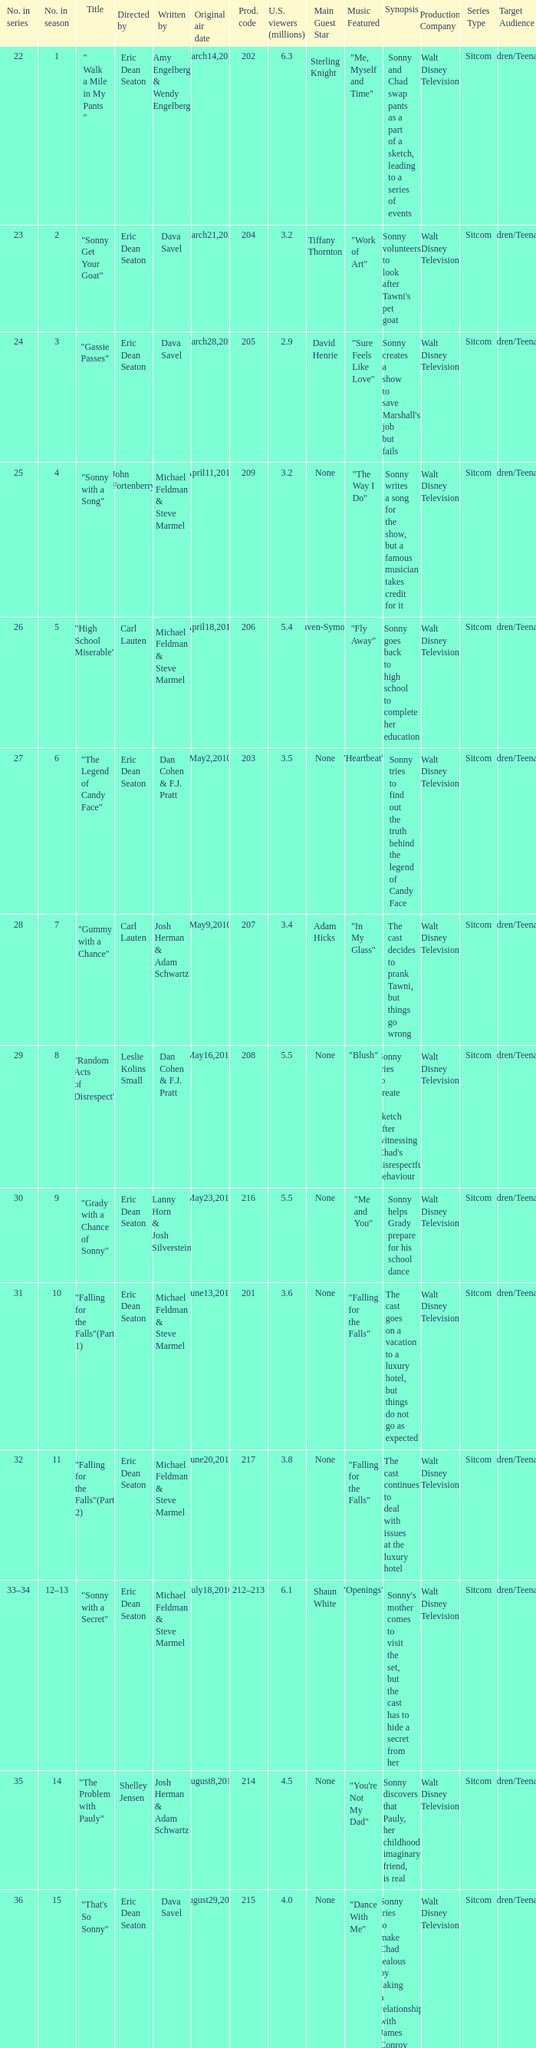Could you help me parse every detail presented in this table? {'header': ['No. in series', 'No. in season', 'Title', 'Directed by', 'Written by', 'Original air date', 'Prod. code', 'U.S. viewers (millions)', 'Main Guest Star', 'Music Featured', 'Synopsis', 'Production Company', 'Series Type', 'Target Audience'], 'rows': [['22', '1', '" Walk a Mile in My Pants "', 'Eric Dean Seaton', 'Amy Engelberg & Wendy Engelberg', 'March14,2010', '202', '6.3', 'Sterling Knight', '"Me, Myself and Time"', 'Sonny and Chad swap pants as a part of a sketch, leading to a series of events', 'Walt Disney Television', 'Sitcom', 'Children/Teenagers'], ['23', '2', '"Sonny Get Your Goat"', 'Eric Dean Seaton', 'Dava Savel', 'March21,2010', '204', '3.2', 'Tiffany Thornton', '"Work of Art"', "Sonny volunteers to look after Tawni's pet goat", 'Walt Disney Television', 'Sitcom', 'Children/Teenagers'], ['24', '3', '"Gassie Passes"', 'Eric Dean Seaton', 'Dava Savel', 'March28,2010', '205', '2.9', 'David Henrie', '"Sure Feels Like Love"', "Sonny creates a show to save Marshall's job but fails", 'Walt Disney Television', 'Sitcom', 'Children/Teenagers'], ['25', '4', '"Sonny with a Song"', 'John Fortenberry', 'Michael Feldman & Steve Marmel', 'April11,2010', '209', '3.2', 'None', '"The Way I Do"', 'Sonny writes a song for the show, but a famous musician takes credit for it', 'Walt Disney Television', 'Sitcom', 'Children/Teenagers'], ['26', '5', '"High School Miserable"', 'Carl Lauten', 'Michael Feldman & Steve Marmel', 'April18,2010', '206', '5.4', 'Raven-Symone', '"Fly Away"', 'Sonny goes back to high school to complete her education', 'Walt Disney Television', 'Sitcom', 'Children/Teenagers'], ['27', '6', '"The Legend of Candy Face"', 'Eric Dean Seaton', 'Dan Cohen & F.J. Pratt', 'May2,2010', '203', '3.5', 'None', '"Heartbeat"', 'Sonny tries to find out the truth behind the legend of Candy Face', 'Walt Disney Television', 'Sitcom', 'Children/Teenagers'], ['28', '7', '"Gummy with a Chance"', 'Carl Lauten', 'Josh Herman & Adam Schwartz', 'May9,2010', '207', '3.4', 'Adam Hicks', '"In My Glass"', 'The cast decides to prank Tawni, but things go wrong', 'Walt Disney Television', 'Sitcom', 'Children/Teenagers'], ['29', '8', '"Random Acts of Disrespect"', 'Leslie Kolins Small', 'Dan Cohen & F.J. Pratt', 'May16,2010', '208', '5.5', 'None', '"Blush"', "Sonny tries to create a sketch after witnessing Chad's disrespectful behaviour", 'Walt Disney Television', 'Sitcom', 'Children/Teenagers'], ['30', '9', '"Grady with a Chance of Sonny"', 'Eric Dean Seaton', 'Lanny Horn & Josh Silverstein', 'May23,2010', '216', '5.5', 'None', '"Me and You"', 'Sonny helps Grady prepare for his school dance', 'Walt Disney Television', 'Sitcom', 'Children/Teenagers'], ['31', '10', '"Falling for the Falls"(Part 1)', 'Eric Dean Seaton', 'Michael Feldman & Steve Marmel', 'June13,2010', '201', '3.6', 'None', '"Falling for the Falls"', 'The cast goes on a vacation to a luxury hotel, but things do not go as expected', 'Walt Disney Television', 'Sitcom', 'Children/Teenagers'], ['32', '11', '"Falling for the Falls"(Part 2)', 'Eric Dean Seaton', 'Michael Feldman & Steve Marmel', 'June20,2010', '217', '3.8', 'None', '"Falling for the Falls"', 'The cast continues to deal with issues at the luxury hotel', 'Walt Disney Television', 'Sitcom', 'Children/Teenagers'], ['33–34', '12–13', '"Sonny with a Secret"', 'Eric Dean Seaton', 'Michael Feldman & Steve Marmel', 'July18,2010', '212–213', '6.1', 'Shaun White', '"Openings"', "Sonny's mother comes to visit the set, but the cast has to hide a secret from her", 'Walt Disney Television', 'Sitcom', 'Children/Teenagers'], ['35', '14', '"The Problem with Pauly"', 'Shelley Jensen', 'Josh Herman & Adam Schwartz', 'August8,2010', '214', '4.5', 'None', '"You\'re Not My Dad"', 'Sonny discovers that Pauly, her childhood imaginary friend, is real', 'Walt Disney Television', 'Sitcom', 'Children/Teenagers'], ['36', '15', '"That\'s So Sonny"', 'Eric Dean Seaton', 'Dava Savel', 'August29,2010', '215', '4.0', 'None', '"Dance With Me"', 'Sonny tries to make Chad jealous by faking a relationship with James Conroy', 'Walt Disney Television', 'Sitcom', 'Children/Teenagers'], ['37', '16', '"Chad Without a Chance"', 'Eric Dean Seaton', 'Amy Engelberg & Wendy Engelberg', 'September19,2010', '210', '4.0', 'None', '"Brother Nature"', 'Sonny and the cast help Chad after he injures himself', 'Walt Disney Television', 'Sitcom', 'Children/Teenagers'], ['38', '17', '"My Two Chads"', 'Eric Dean Seaton', 'Dan Cohen & F.J. Pratt', 'September26,2010', '211', '4.0', 'None', '"Freak The Freak Out"', 'Chad brings his stunt double on set, causing problems with the cast', 'Walt Disney Television', 'Sitcom', 'Children/Teenagers'], ['39', '18', '"A So Random! Halloween Special"', 'Eric Dean Seaton', 'Josh Herman & Adam Schwartz', 'October17,2010', '226', '4.0', 'None', '"Monster"', 'The cast prepares for a Halloween themed episode of the show', 'Walt Disney Television', 'Sitcom', 'Children/Teenagers'], ['40', '19', '"Sonny with a 100% Chance of Meddling"', 'Ron Mosely', 'Lanny Horn & Josh Silverstein', 'October24,2010', '219', '4.7', 'Debby Ryan', '"Gray Horizon"', "Sonny tries to meddle in Tawni's and Chad's personal lives", 'Walt Disney Television', 'Sitcom', 'Children/Teenagers'], ['41', '20', '"Dakota\'s Revenge"', 'Eric Dean Seaton', 'Dava Savel', 'November14,2010', '223', '3.7', 'None', '"Goodnight"', 'Dakota returns to the show seeking revenge, causing chaos on set', 'Walt Disney Television', 'Sitcom', 'Children/Teenagers'], ['42', '21', '"Sonny with a Kiss"', 'Eric Dean Seaton', 'Ellen Byron & Lissa Kapstrom', 'November21,2010', '220', '3.6', 'None', '"Beautiful Love"', 'Sonny and Chad share their first kiss on air, but issues arise', 'Walt Disney Television', 'Sitcom', 'Children/Teenagers'], ['43', '22', '"A So Random! Holiday Special"', 'Eric Dean Seaton', 'Michael Feldman & Steve Marmel', 'November28,2010', '218', '3.8', 'None', '"Winter Wonderland"', 'The cast celebrates the holidays with sketches, music, and special guests', 'Walt Disney Television', 'Sitcom', 'Children/Teenagers'], ['44', '23', '"Sonny with a Grant"', 'Eric Dean Seaton', 'Michael Feldman & Steve Marmel', 'December5,2010', '221', '4.0', 'None', '"Only in My Dreams"', 'Sonny must create a show to impress a grant committee', 'Walt Disney Television', 'Sitcom', 'Children/Teenagers'], ['45', '24', '"Marshall with a Chance"', 'Shannon Flynn', 'Carla Banks Waddles', 'December12,2010', '224', '3.2', 'None', '"Magic Mirror"', 'Marshall is given his own show, causing jealousy with the cast', 'Walt Disney Television', 'Sitcom', 'Children/Teenagers'], ['46', '25', '"Sonny with a Choice"', 'Eric Dean Seaton', 'Dan Cohen & F.J. Pratt', 'December19,2010', '222', '4.7', 'None', '"Love Goes On"', 'Sonny must choose between Chad and James Conroy', 'Walt Disney Television', 'Sitcom', 'Children/Teenagers']]} Who directed the episode that 6.3 million u.s. viewers saw? Eric Dean Seaton. 